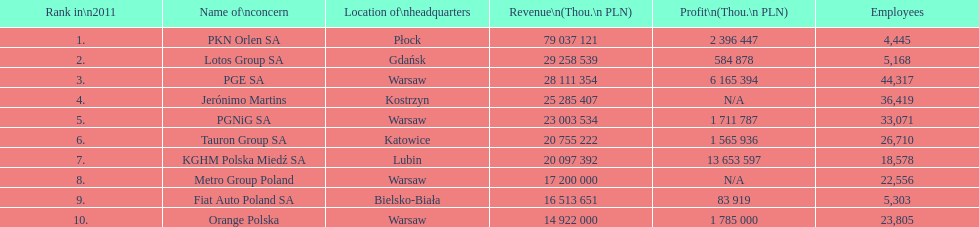Which organization had the highest number of workers? PGE SA. 